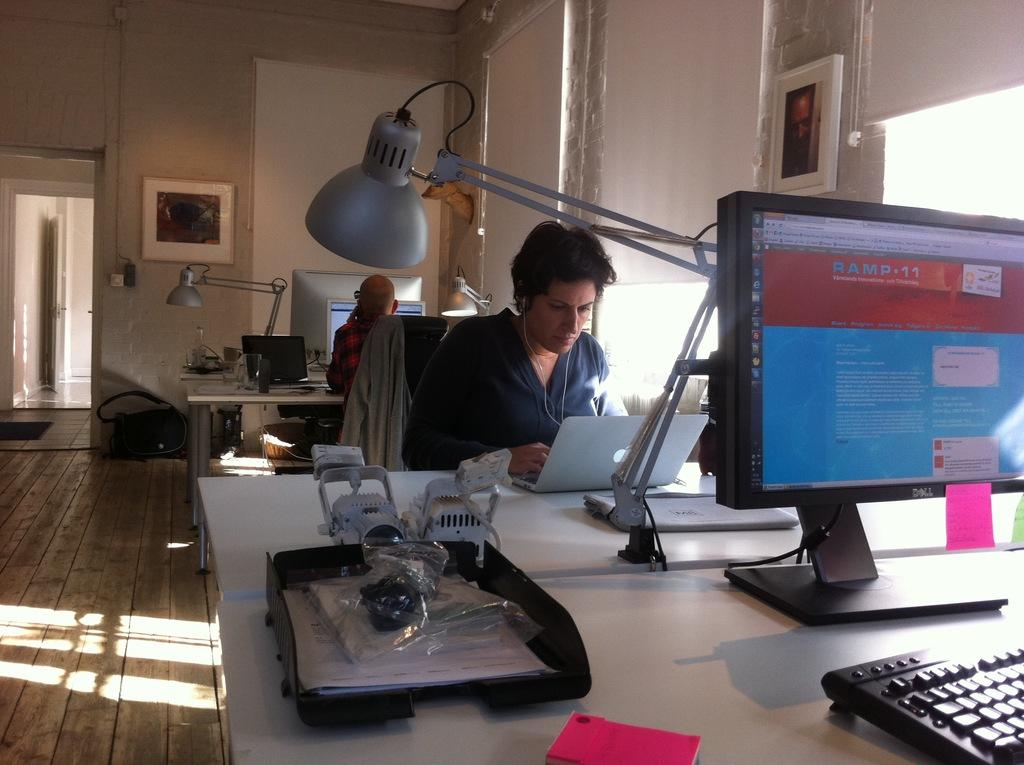How many people are in the image? There are two persons in the image. What are the persons doing in the image? The persons are sitting on chairs and looking at a computer. What can be seen in the room where the persons are sitting? There are frames, curtains, windows, a table, computers, and keyboards in the room. What type of flag is being waved by the person in the image? There is no flag present in the image; the persons are sitting and looking at a computer. What authority figure is present in the image? There is no authority figure mentioned or depicted in the image. 